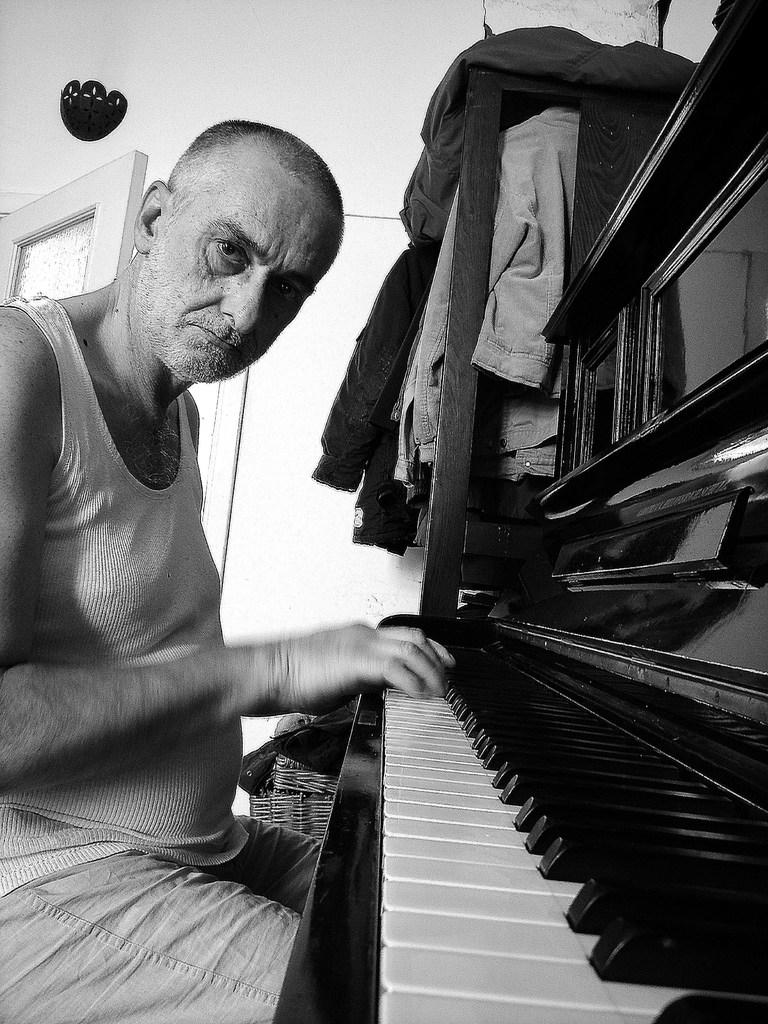Who is the person in the image? There is a man in the image. What is the man wearing? The man is wearing a white dress. What is the man doing in the image? The man is sitting and playing a piano. What instrument is the man playing? The man is playing a piano. Can you describe the location of the piano in the image? There is a piano in front of the man. What other objects can be seen in the image? There are clothes visible in the top right of the image and a door visible in the top left of the image. Where is the nest located in the image? There is no nest present in the image. 